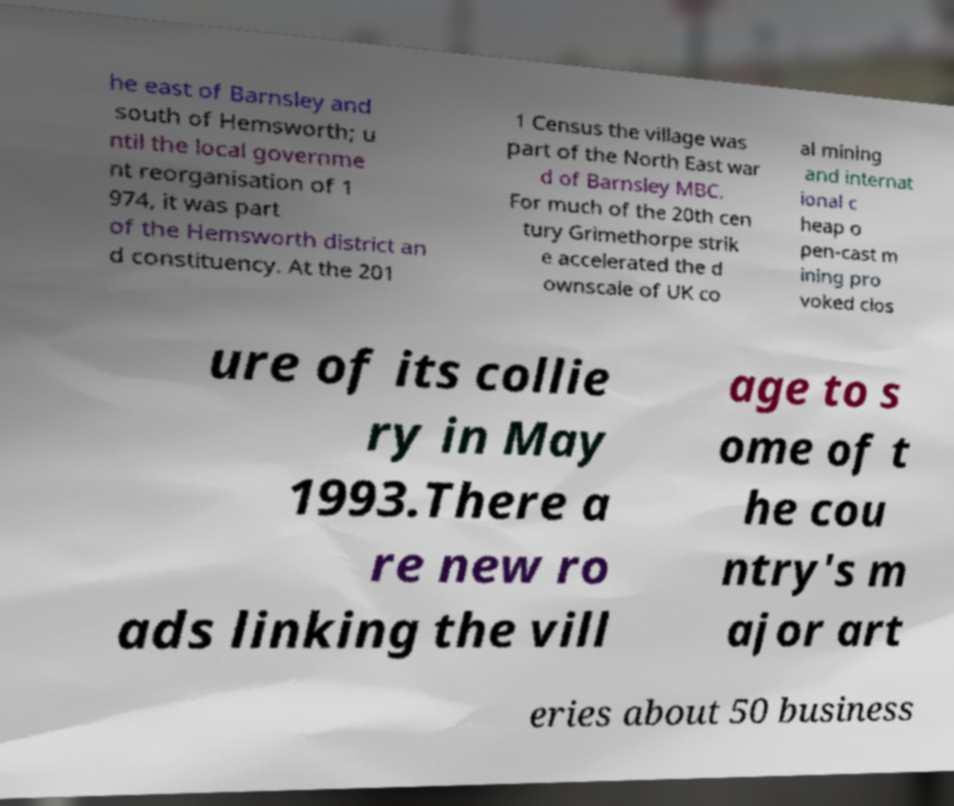There's text embedded in this image that I need extracted. Can you transcribe it verbatim? he east of Barnsley and south of Hemsworth; u ntil the local governme nt reorganisation of 1 974, it was part of the Hemsworth district an d constituency. At the 201 1 Census the village was part of the North East war d of Barnsley MBC. For much of the 20th cen tury Grimethorpe strik e accelerated the d ownscale of UK co al mining and internat ional c heap o pen-cast m ining pro voked clos ure of its collie ry in May 1993.There a re new ro ads linking the vill age to s ome of t he cou ntry's m ajor art eries about 50 business 